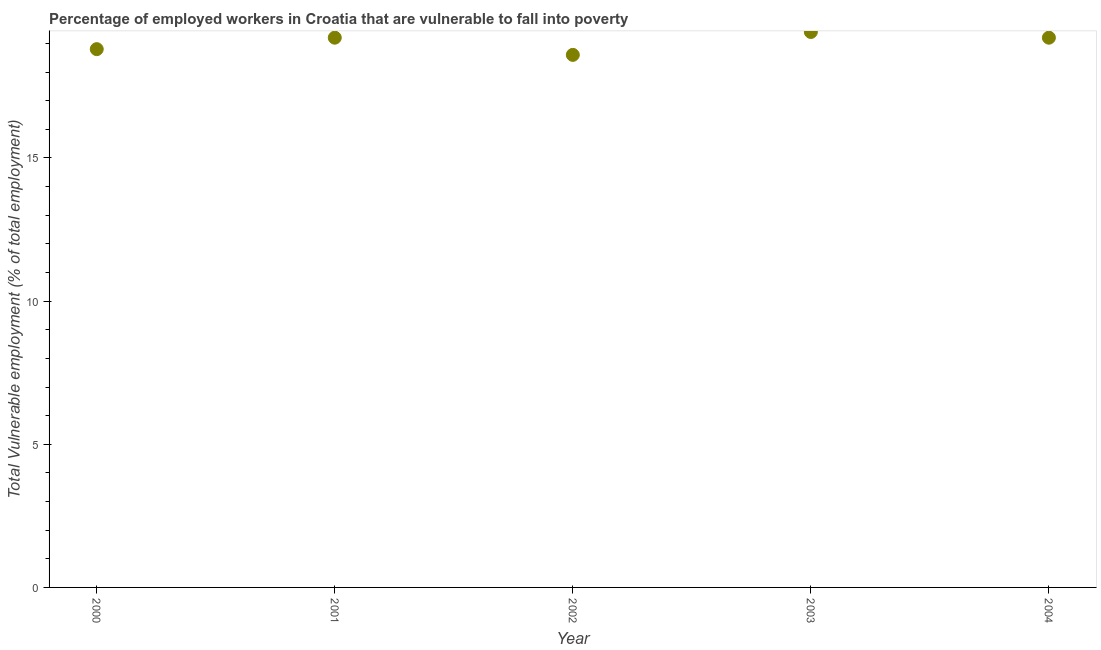What is the total vulnerable employment in 2003?
Your answer should be compact. 19.4. Across all years, what is the maximum total vulnerable employment?
Provide a short and direct response. 19.4. Across all years, what is the minimum total vulnerable employment?
Your response must be concise. 18.6. In which year was the total vulnerable employment maximum?
Ensure brevity in your answer.  2003. What is the sum of the total vulnerable employment?
Offer a very short reply. 95.2. What is the difference between the total vulnerable employment in 2001 and 2003?
Provide a short and direct response. -0.2. What is the average total vulnerable employment per year?
Your response must be concise. 19.04. What is the median total vulnerable employment?
Give a very brief answer. 19.2. What is the ratio of the total vulnerable employment in 2000 to that in 2004?
Your answer should be very brief. 0.98. Is the total vulnerable employment in 2000 less than that in 2003?
Make the answer very short. Yes. What is the difference between the highest and the second highest total vulnerable employment?
Keep it short and to the point. 0.2. What is the difference between the highest and the lowest total vulnerable employment?
Your answer should be compact. 0.8. What is the difference between two consecutive major ticks on the Y-axis?
Keep it short and to the point. 5. Are the values on the major ticks of Y-axis written in scientific E-notation?
Give a very brief answer. No. Does the graph contain any zero values?
Make the answer very short. No. What is the title of the graph?
Offer a very short reply. Percentage of employed workers in Croatia that are vulnerable to fall into poverty. What is the label or title of the X-axis?
Offer a very short reply. Year. What is the label or title of the Y-axis?
Make the answer very short. Total Vulnerable employment (% of total employment). What is the Total Vulnerable employment (% of total employment) in 2000?
Provide a short and direct response. 18.8. What is the Total Vulnerable employment (% of total employment) in 2001?
Give a very brief answer. 19.2. What is the Total Vulnerable employment (% of total employment) in 2002?
Keep it short and to the point. 18.6. What is the Total Vulnerable employment (% of total employment) in 2003?
Offer a terse response. 19.4. What is the Total Vulnerable employment (% of total employment) in 2004?
Your answer should be very brief. 19.2. What is the difference between the Total Vulnerable employment (% of total employment) in 2000 and 2001?
Offer a terse response. -0.4. What is the difference between the Total Vulnerable employment (% of total employment) in 2000 and 2002?
Offer a very short reply. 0.2. What is the difference between the Total Vulnerable employment (% of total employment) in 2000 and 2003?
Offer a terse response. -0.6. What is the difference between the Total Vulnerable employment (% of total employment) in 2000 and 2004?
Provide a short and direct response. -0.4. What is the difference between the Total Vulnerable employment (% of total employment) in 2001 and 2002?
Make the answer very short. 0.6. What is the difference between the Total Vulnerable employment (% of total employment) in 2001 and 2004?
Give a very brief answer. 0. What is the difference between the Total Vulnerable employment (% of total employment) in 2003 and 2004?
Give a very brief answer. 0.2. What is the ratio of the Total Vulnerable employment (% of total employment) in 2000 to that in 2001?
Your answer should be very brief. 0.98. What is the ratio of the Total Vulnerable employment (% of total employment) in 2001 to that in 2002?
Offer a terse response. 1.03. What is the ratio of the Total Vulnerable employment (% of total employment) in 2001 to that in 2003?
Offer a very short reply. 0.99. 